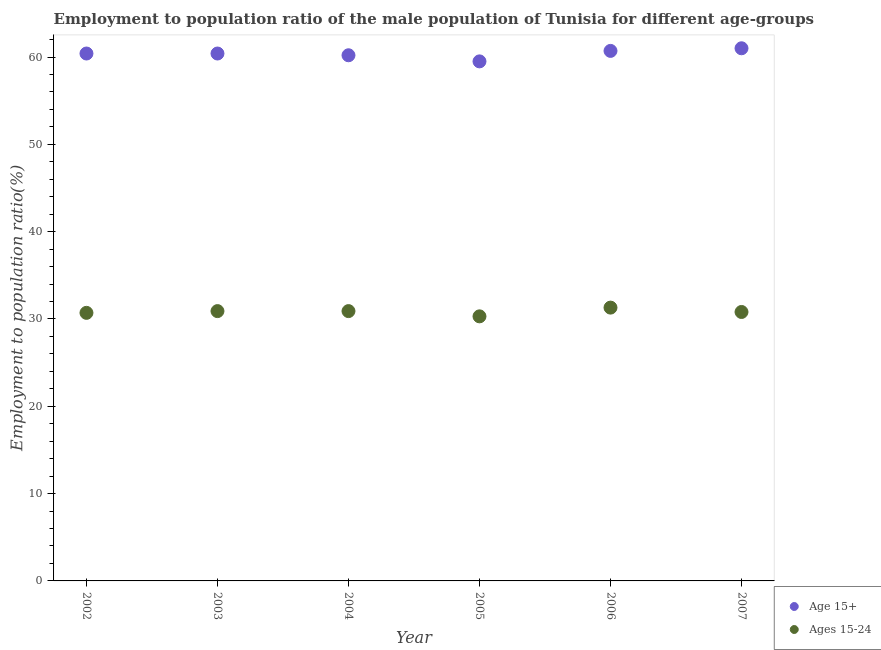What is the employment to population ratio(age 15-24) in 2007?
Your answer should be compact. 30.8. Across all years, what is the minimum employment to population ratio(age 15-24)?
Your answer should be very brief. 30.3. In which year was the employment to population ratio(age 15-24) minimum?
Offer a very short reply. 2005. What is the total employment to population ratio(age 15+) in the graph?
Your answer should be compact. 362.2. What is the difference between the employment to population ratio(age 15+) in 2002 and that in 2005?
Your answer should be very brief. 0.9. What is the difference between the employment to population ratio(age 15-24) in 2003 and the employment to population ratio(age 15+) in 2006?
Your answer should be very brief. -29.8. What is the average employment to population ratio(age 15-24) per year?
Make the answer very short. 30.82. In the year 2007, what is the difference between the employment to population ratio(age 15-24) and employment to population ratio(age 15+)?
Offer a very short reply. -30.2. In how many years, is the employment to population ratio(age 15+) greater than 16 %?
Keep it short and to the point. 6. What is the ratio of the employment to population ratio(age 15+) in 2002 to that in 2006?
Your response must be concise. 1. Is the employment to population ratio(age 15+) in 2003 less than that in 2005?
Your response must be concise. No. What is the difference between the highest and the second highest employment to population ratio(age 15-24)?
Offer a very short reply. 0.4. What is the difference between the highest and the lowest employment to population ratio(age 15+)?
Provide a short and direct response. 1.5. In how many years, is the employment to population ratio(age 15-24) greater than the average employment to population ratio(age 15-24) taken over all years?
Make the answer very short. 3. Is the sum of the employment to population ratio(age 15+) in 2005 and 2006 greater than the maximum employment to population ratio(age 15-24) across all years?
Your response must be concise. Yes. Is the employment to population ratio(age 15+) strictly less than the employment to population ratio(age 15-24) over the years?
Make the answer very short. No. Does the graph contain any zero values?
Offer a terse response. No. Does the graph contain grids?
Keep it short and to the point. No. Where does the legend appear in the graph?
Ensure brevity in your answer.  Bottom right. How many legend labels are there?
Ensure brevity in your answer.  2. What is the title of the graph?
Your answer should be very brief. Employment to population ratio of the male population of Tunisia for different age-groups. Does "Foreign Liabilities" appear as one of the legend labels in the graph?
Keep it short and to the point. No. What is the label or title of the X-axis?
Your answer should be compact. Year. What is the label or title of the Y-axis?
Your response must be concise. Employment to population ratio(%). What is the Employment to population ratio(%) in Age 15+ in 2002?
Offer a very short reply. 60.4. What is the Employment to population ratio(%) in Ages 15-24 in 2002?
Provide a short and direct response. 30.7. What is the Employment to population ratio(%) of Age 15+ in 2003?
Provide a succinct answer. 60.4. What is the Employment to population ratio(%) of Ages 15-24 in 2003?
Offer a terse response. 30.9. What is the Employment to population ratio(%) in Age 15+ in 2004?
Give a very brief answer. 60.2. What is the Employment to population ratio(%) in Ages 15-24 in 2004?
Your answer should be compact. 30.9. What is the Employment to population ratio(%) of Age 15+ in 2005?
Your answer should be very brief. 59.5. What is the Employment to population ratio(%) in Ages 15-24 in 2005?
Offer a terse response. 30.3. What is the Employment to population ratio(%) in Age 15+ in 2006?
Provide a succinct answer. 60.7. What is the Employment to population ratio(%) of Ages 15-24 in 2006?
Provide a short and direct response. 31.3. What is the Employment to population ratio(%) in Age 15+ in 2007?
Offer a terse response. 61. What is the Employment to population ratio(%) in Ages 15-24 in 2007?
Provide a succinct answer. 30.8. Across all years, what is the maximum Employment to population ratio(%) of Age 15+?
Ensure brevity in your answer.  61. Across all years, what is the maximum Employment to population ratio(%) in Ages 15-24?
Your answer should be compact. 31.3. Across all years, what is the minimum Employment to population ratio(%) of Age 15+?
Keep it short and to the point. 59.5. Across all years, what is the minimum Employment to population ratio(%) of Ages 15-24?
Ensure brevity in your answer.  30.3. What is the total Employment to population ratio(%) in Age 15+ in the graph?
Offer a terse response. 362.2. What is the total Employment to population ratio(%) in Ages 15-24 in the graph?
Offer a terse response. 184.9. What is the difference between the Employment to population ratio(%) of Age 15+ in 2002 and that in 2003?
Provide a short and direct response. 0. What is the difference between the Employment to population ratio(%) in Ages 15-24 in 2002 and that in 2003?
Your response must be concise. -0.2. What is the difference between the Employment to population ratio(%) in Ages 15-24 in 2002 and that in 2004?
Ensure brevity in your answer.  -0.2. What is the difference between the Employment to population ratio(%) in Age 15+ in 2002 and that in 2006?
Your response must be concise. -0.3. What is the difference between the Employment to population ratio(%) of Ages 15-24 in 2002 and that in 2006?
Give a very brief answer. -0.6. What is the difference between the Employment to population ratio(%) in Ages 15-24 in 2002 and that in 2007?
Your response must be concise. -0.1. What is the difference between the Employment to population ratio(%) in Ages 15-24 in 2003 and that in 2004?
Your answer should be compact. 0. What is the difference between the Employment to population ratio(%) in Age 15+ in 2003 and that in 2005?
Offer a terse response. 0.9. What is the difference between the Employment to population ratio(%) of Ages 15-24 in 2003 and that in 2006?
Ensure brevity in your answer.  -0.4. What is the difference between the Employment to population ratio(%) of Ages 15-24 in 2003 and that in 2007?
Make the answer very short. 0.1. What is the difference between the Employment to population ratio(%) of Age 15+ in 2004 and that in 2005?
Offer a terse response. 0.7. What is the difference between the Employment to population ratio(%) in Ages 15-24 in 2004 and that in 2005?
Your answer should be very brief. 0.6. What is the difference between the Employment to population ratio(%) in Age 15+ in 2004 and that in 2006?
Offer a terse response. -0.5. What is the difference between the Employment to population ratio(%) of Ages 15-24 in 2004 and that in 2006?
Provide a short and direct response. -0.4. What is the difference between the Employment to population ratio(%) in Ages 15-24 in 2004 and that in 2007?
Keep it short and to the point. 0.1. What is the difference between the Employment to population ratio(%) of Age 15+ in 2002 and the Employment to population ratio(%) of Ages 15-24 in 2003?
Keep it short and to the point. 29.5. What is the difference between the Employment to population ratio(%) of Age 15+ in 2002 and the Employment to population ratio(%) of Ages 15-24 in 2004?
Your answer should be compact. 29.5. What is the difference between the Employment to population ratio(%) of Age 15+ in 2002 and the Employment to population ratio(%) of Ages 15-24 in 2005?
Your answer should be compact. 30.1. What is the difference between the Employment to population ratio(%) in Age 15+ in 2002 and the Employment to population ratio(%) in Ages 15-24 in 2006?
Your answer should be very brief. 29.1. What is the difference between the Employment to population ratio(%) in Age 15+ in 2002 and the Employment to population ratio(%) in Ages 15-24 in 2007?
Provide a succinct answer. 29.6. What is the difference between the Employment to population ratio(%) in Age 15+ in 2003 and the Employment to population ratio(%) in Ages 15-24 in 2004?
Offer a terse response. 29.5. What is the difference between the Employment to population ratio(%) in Age 15+ in 2003 and the Employment to population ratio(%) in Ages 15-24 in 2005?
Your answer should be very brief. 30.1. What is the difference between the Employment to population ratio(%) of Age 15+ in 2003 and the Employment to population ratio(%) of Ages 15-24 in 2006?
Keep it short and to the point. 29.1. What is the difference between the Employment to population ratio(%) of Age 15+ in 2003 and the Employment to population ratio(%) of Ages 15-24 in 2007?
Keep it short and to the point. 29.6. What is the difference between the Employment to population ratio(%) in Age 15+ in 2004 and the Employment to population ratio(%) in Ages 15-24 in 2005?
Offer a very short reply. 29.9. What is the difference between the Employment to population ratio(%) in Age 15+ in 2004 and the Employment to population ratio(%) in Ages 15-24 in 2006?
Your answer should be compact. 28.9. What is the difference between the Employment to population ratio(%) in Age 15+ in 2004 and the Employment to population ratio(%) in Ages 15-24 in 2007?
Make the answer very short. 29.4. What is the difference between the Employment to population ratio(%) of Age 15+ in 2005 and the Employment to population ratio(%) of Ages 15-24 in 2006?
Keep it short and to the point. 28.2. What is the difference between the Employment to population ratio(%) of Age 15+ in 2005 and the Employment to population ratio(%) of Ages 15-24 in 2007?
Your answer should be very brief. 28.7. What is the difference between the Employment to population ratio(%) of Age 15+ in 2006 and the Employment to population ratio(%) of Ages 15-24 in 2007?
Keep it short and to the point. 29.9. What is the average Employment to population ratio(%) in Age 15+ per year?
Ensure brevity in your answer.  60.37. What is the average Employment to population ratio(%) of Ages 15-24 per year?
Offer a very short reply. 30.82. In the year 2002, what is the difference between the Employment to population ratio(%) of Age 15+ and Employment to population ratio(%) of Ages 15-24?
Provide a succinct answer. 29.7. In the year 2003, what is the difference between the Employment to population ratio(%) in Age 15+ and Employment to population ratio(%) in Ages 15-24?
Your response must be concise. 29.5. In the year 2004, what is the difference between the Employment to population ratio(%) in Age 15+ and Employment to population ratio(%) in Ages 15-24?
Offer a terse response. 29.3. In the year 2005, what is the difference between the Employment to population ratio(%) in Age 15+ and Employment to population ratio(%) in Ages 15-24?
Your answer should be very brief. 29.2. In the year 2006, what is the difference between the Employment to population ratio(%) in Age 15+ and Employment to population ratio(%) in Ages 15-24?
Provide a succinct answer. 29.4. In the year 2007, what is the difference between the Employment to population ratio(%) of Age 15+ and Employment to population ratio(%) of Ages 15-24?
Offer a terse response. 30.2. What is the ratio of the Employment to population ratio(%) of Ages 15-24 in 2002 to that in 2003?
Offer a terse response. 0.99. What is the ratio of the Employment to population ratio(%) in Age 15+ in 2002 to that in 2004?
Offer a terse response. 1. What is the ratio of the Employment to population ratio(%) of Age 15+ in 2002 to that in 2005?
Offer a terse response. 1.02. What is the ratio of the Employment to population ratio(%) of Ages 15-24 in 2002 to that in 2005?
Your answer should be very brief. 1.01. What is the ratio of the Employment to population ratio(%) in Ages 15-24 in 2002 to that in 2006?
Your answer should be compact. 0.98. What is the ratio of the Employment to population ratio(%) in Age 15+ in 2002 to that in 2007?
Your answer should be compact. 0.99. What is the ratio of the Employment to population ratio(%) in Age 15+ in 2003 to that in 2004?
Ensure brevity in your answer.  1. What is the ratio of the Employment to population ratio(%) of Ages 15-24 in 2003 to that in 2004?
Your answer should be compact. 1. What is the ratio of the Employment to population ratio(%) of Age 15+ in 2003 to that in 2005?
Make the answer very short. 1.02. What is the ratio of the Employment to population ratio(%) in Ages 15-24 in 2003 to that in 2005?
Give a very brief answer. 1.02. What is the ratio of the Employment to population ratio(%) in Ages 15-24 in 2003 to that in 2006?
Ensure brevity in your answer.  0.99. What is the ratio of the Employment to population ratio(%) of Age 15+ in 2003 to that in 2007?
Offer a terse response. 0.99. What is the ratio of the Employment to population ratio(%) of Ages 15-24 in 2003 to that in 2007?
Give a very brief answer. 1. What is the ratio of the Employment to population ratio(%) of Age 15+ in 2004 to that in 2005?
Give a very brief answer. 1.01. What is the ratio of the Employment to population ratio(%) of Ages 15-24 in 2004 to that in 2005?
Keep it short and to the point. 1.02. What is the ratio of the Employment to population ratio(%) of Ages 15-24 in 2004 to that in 2006?
Your answer should be very brief. 0.99. What is the ratio of the Employment to population ratio(%) in Age 15+ in 2004 to that in 2007?
Give a very brief answer. 0.99. What is the ratio of the Employment to population ratio(%) of Age 15+ in 2005 to that in 2006?
Offer a very short reply. 0.98. What is the ratio of the Employment to population ratio(%) in Ages 15-24 in 2005 to that in 2006?
Keep it short and to the point. 0.97. What is the ratio of the Employment to population ratio(%) of Age 15+ in 2005 to that in 2007?
Make the answer very short. 0.98. What is the ratio of the Employment to population ratio(%) of Ages 15-24 in 2005 to that in 2007?
Give a very brief answer. 0.98. What is the ratio of the Employment to population ratio(%) in Age 15+ in 2006 to that in 2007?
Offer a terse response. 1. What is the ratio of the Employment to population ratio(%) in Ages 15-24 in 2006 to that in 2007?
Offer a very short reply. 1.02. What is the difference between the highest and the second highest Employment to population ratio(%) of Ages 15-24?
Your answer should be compact. 0.4. What is the difference between the highest and the lowest Employment to population ratio(%) of Age 15+?
Make the answer very short. 1.5. 